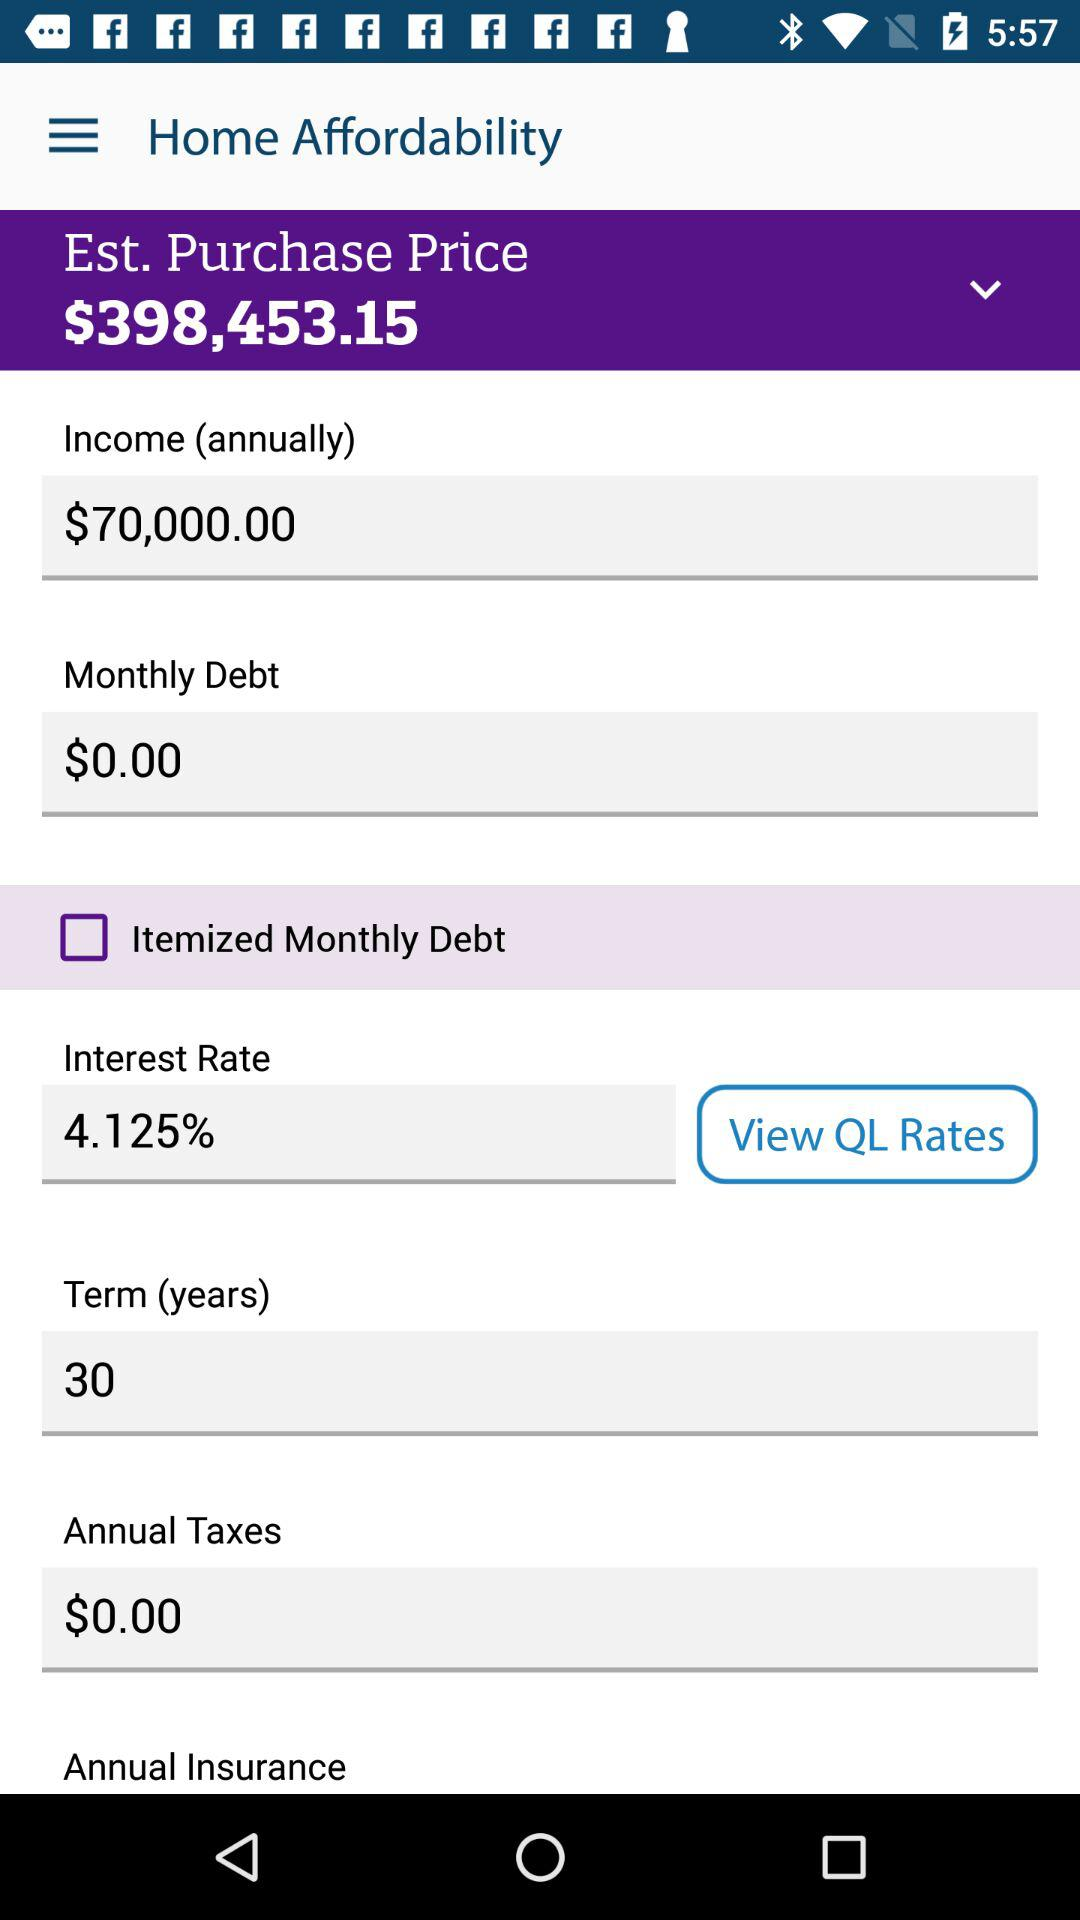What is the "Term" in years? The term is 30 years. 